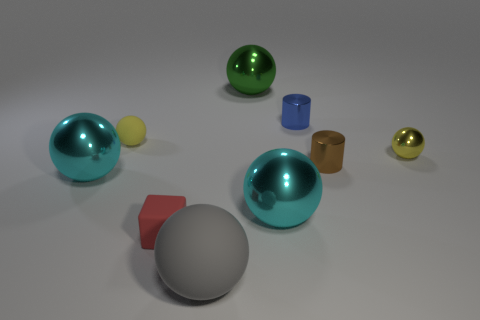Subtract all rubber balls. How many balls are left? 4 Subtract all green balls. How many balls are left? 5 Add 1 tiny gray matte cubes. How many objects exist? 10 Subtract all cubes. How many objects are left? 8 Subtract 1 cylinders. How many cylinders are left? 1 Subtract all gray spheres. Subtract all blue cubes. How many spheres are left? 5 Subtract all purple blocks. How many gray spheres are left? 1 Subtract all rubber cubes. Subtract all brown metal cylinders. How many objects are left? 7 Add 7 tiny yellow objects. How many tiny yellow objects are left? 9 Add 6 small red things. How many small red things exist? 7 